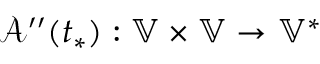<formula> <loc_0><loc_0><loc_500><loc_500>\mathcal { A } ^ { \prime \prime } ( t _ { * } ) \colon \mathbb { V } \times \mathbb { V } \to \mathbb { V } ^ { * }</formula> 